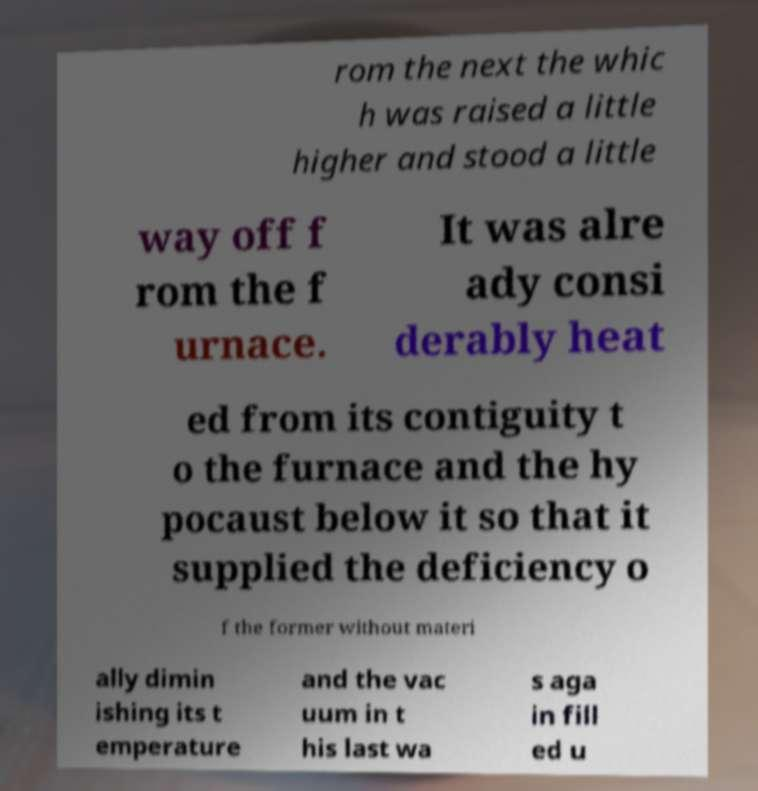For documentation purposes, I need the text within this image transcribed. Could you provide that? rom the next the whic h was raised a little higher and stood a little way off f rom the f urnace. It was alre ady consi derably heat ed from its contiguity t o the furnace and the hy pocaust below it so that it supplied the deficiency o f the former without materi ally dimin ishing its t emperature and the vac uum in t his last wa s aga in fill ed u 